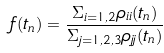Convert formula to latex. <formula><loc_0><loc_0><loc_500><loc_500>f ( t _ { n } ) = \frac { \Sigma _ { i = 1 , 2 } \rho _ { i i } ( t _ { n } ) } { \Sigma _ { j = 1 , 2 , 3 } \rho _ { j j } ( t _ { n } ) }</formula> 